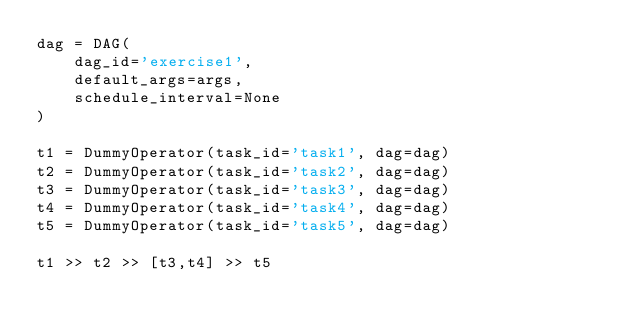<code> <loc_0><loc_0><loc_500><loc_500><_Python_>dag = DAG(
    dag_id='exercise1',
    default_args=args,
    schedule_interval=None
)

t1 = DummyOperator(task_id='task1', dag=dag)
t2 = DummyOperator(task_id='task2', dag=dag)
t3 = DummyOperator(task_id='task3', dag=dag)
t4 = DummyOperator(task_id='task4', dag=dag)
t5 = DummyOperator(task_id='task5', dag=dag)

t1 >> t2 >> [t3,t4] >> t5
</code> 